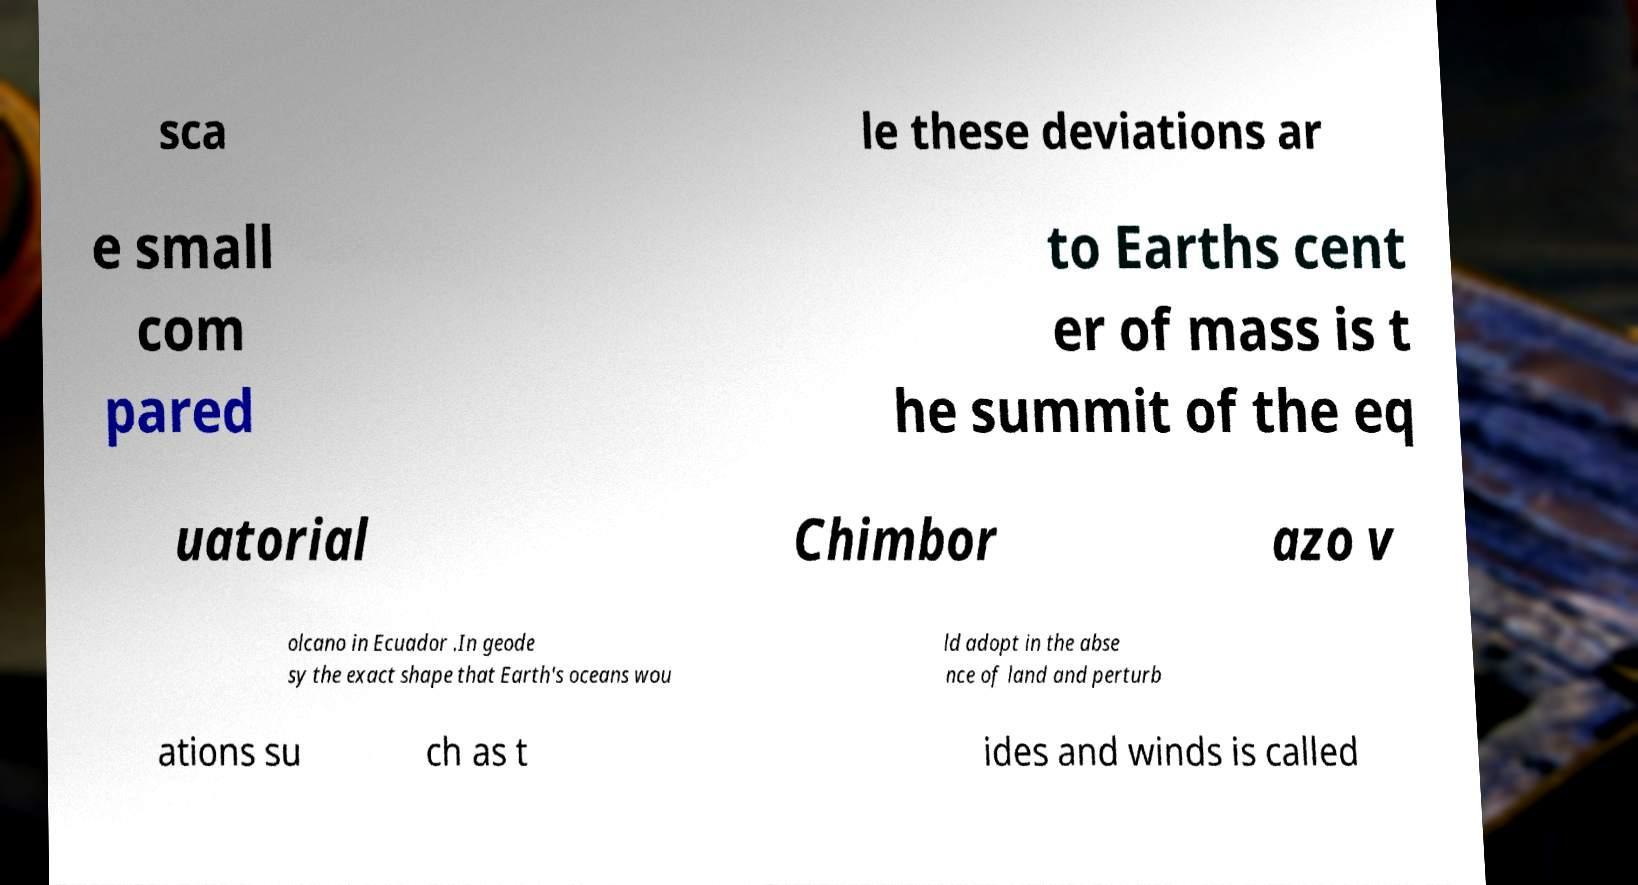Could you assist in decoding the text presented in this image and type it out clearly? sca le these deviations ar e small com pared to Earths cent er of mass is t he summit of the eq uatorial Chimbor azo v olcano in Ecuador .In geode sy the exact shape that Earth's oceans wou ld adopt in the abse nce of land and perturb ations su ch as t ides and winds is called 